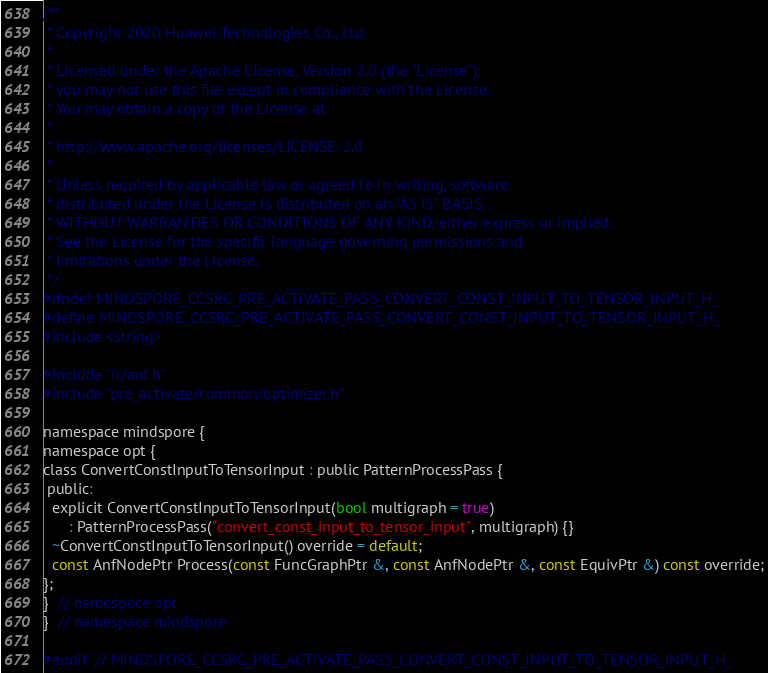Convert code to text. <code><loc_0><loc_0><loc_500><loc_500><_C_>/**
 * Copyright 2020 Huawei Technologies Co., Ltd
 *
 * Licensed under the Apache License, Version 2.0 (the "License");
 * you may not use this file except in compliance with the License.
 * You may obtain a copy of the License at
 *
 * http://www.apache.org/licenses/LICENSE-2.0
 *
 * Unless required by applicable law or agreed to in writing, software
 * distributed under the License is distributed on an "AS IS" BASIS,
 * WITHOUT WARRANTIES OR CONDITIONS OF ANY KIND, either express or implied.
 * See the License for the specific language governing permissions and
 * limitations under the License.
 */
#ifndef MINDSPORE_CCSRC_PRE_ACTIVATE_PASS_CONVERT_CONST_INPUT_TO_TENSOR_INPUT_H_
#define MINDSPORE_CCSRC_PRE_ACTIVATE_PASS_CONVERT_CONST_INPUT_TO_TENSOR_INPUT_H_
#include <string>

#include "ir/anf.h"
#include "pre_activate/common/optimizer.h"

namespace mindspore {
namespace opt {
class ConvertConstInputToTensorInput : public PatternProcessPass {
 public:
  explicit ConvertConstInputToTensorInput(bool multigraph = true)
      : PatternProcessPass("convert_const_input_to_tensor_input", multigraph) {}
  ~ConvertConstInputToTensorInput() override = default;
  const AnfNodePtr Process(const FuncGraphPtr &, const AnfNodePtr &, const EquivPtr &) const override;
};
}  // namespace opt
}  // namespace mindspore

#endif  // MINDSPORE_CCSRC_PRE_ACTIVATE_PASS_CONVERT_CONST_INPUT_TO_TENSOR_INPUT_H_
</code> 